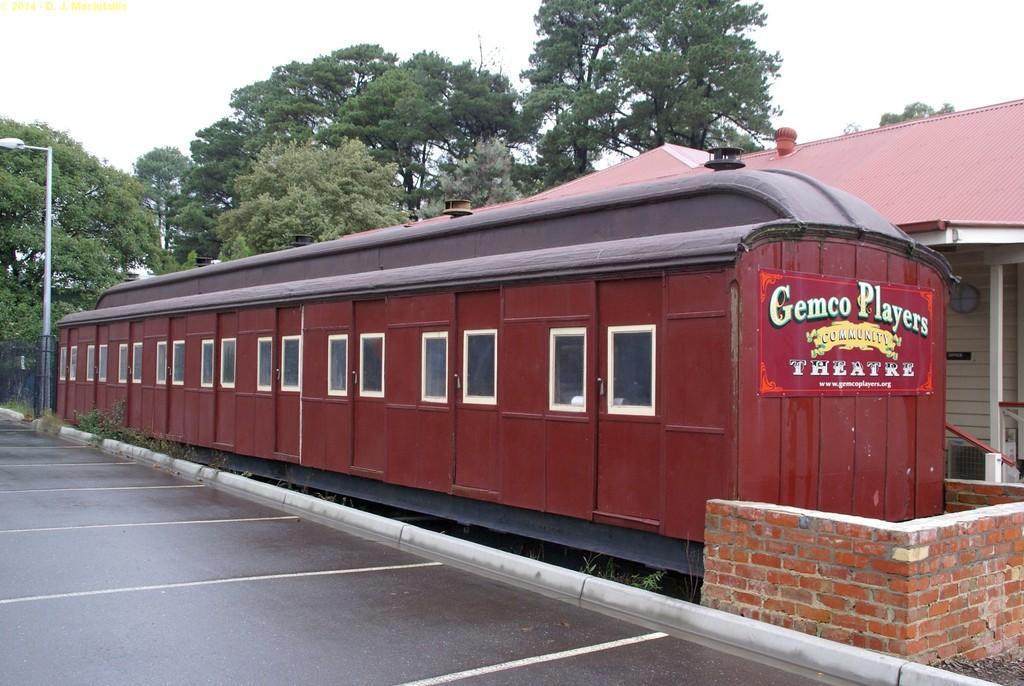Could you give a brief overview of what you see in this image? This image is taken outdoors. On the left side of the image there is a platform. In the background there are a few trees and a street light. In the middle of the there is train. On the right side of the image there is a house with a wall. 